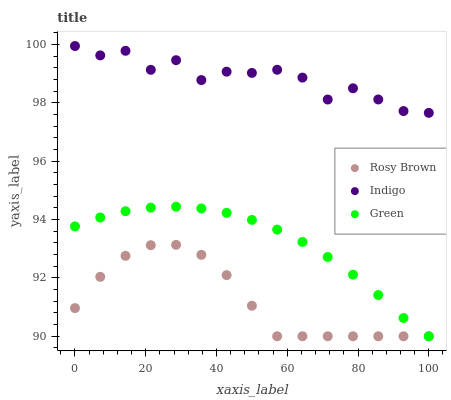Does Rosy Brown have the minimum area under the curve?
Answer yes or no. Yes. Does Indigo have the maximum area under the curve?
Answer yes or no. Yes. Does Indigo have the minimum area under the curve?
Answer yes or no. No. Does Rosy Brown have the maximum area under the curve?
Answer yes or no. No. Is Green the smoothest?
Answer yes or no. Yes. Is Indigo the roughest?
Answer yes or no. Yes. Is Rosy Brown the smoothest?
Answer yes or no. No. Is Rosy Brown the roughest?
Answer yes or no. No. Does Green have the lowest value?
Answer yes or no. Yes. Does Indigo have the lowest value?
Answer yes or no. No. Does Indigo have the highest value?
Answer yes or no. Yes. Does Rosy Brown have the highest value?
Answer yes or no. No. Is Rosy Brown less than Indigo?
Answer yes or no. Yes. Is Indigo greater than Rosy Brown?
Answer yes or no. Yes. Does Green intersect Rosy Brown?
Answer yes or no. Yes. Is Green less than Rosy Brown?
Answer yes or no. No. Is Green greater than Rosy Brown?
Answer yes or no. No. Does Rosy Brown intersect Indigo?
Answer yes or no. No. 